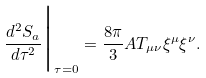<formula> <loc_0><loc_0><loc_500><loc_500>\frac { d ^ { 2 } S _ { a } } { d \tau ^ { 2 } } \Big | _ { \tau = 0 } = \frac { 8 \pi } { 3 } A T _ { \mu \nu } \xi ^ { \mu } \xi ^ { \nu } .</formula> 